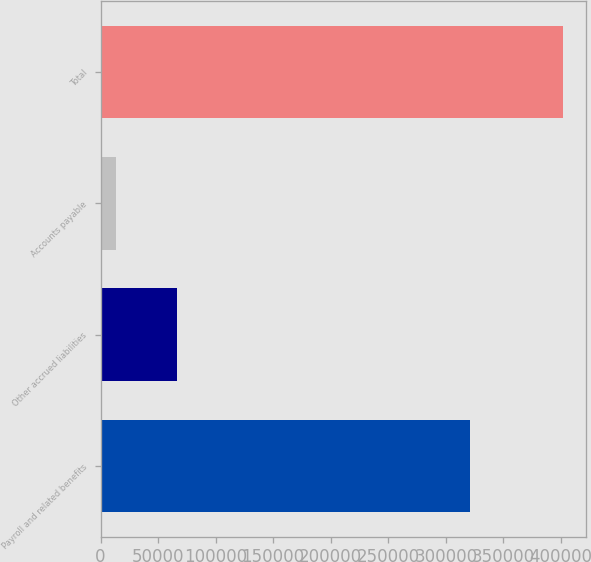Convert chart. <chart><loc_0><loc_0><loc_500><loc_500><bar_chart><fcel>Payroll and related benefits<fcel>Other accrued liabilities<fcel>Accounts payable<fcel>Total<nl><fcel>321430<fcel>66276<fcel>13745<fcel>401451<nl></chart> 